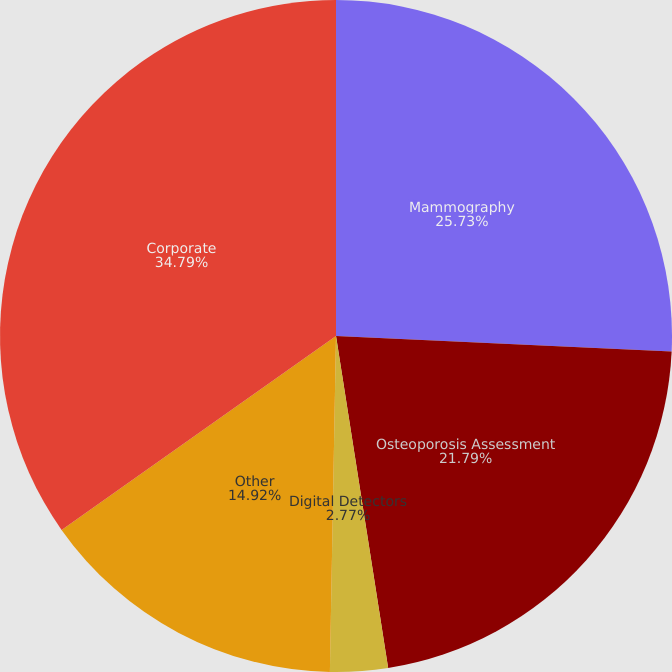<chart> <loc_0><loc_0><loc_500><loc_500><pie_chart><fcel>Mammography<fcel>Osteoporosis Assessment<fcel>Digital Detectors<fcel>Other<fcel>Corporate<nl><fcel>25.73%<fcel>21.79%<fcel>2.77%<fcel>14.92%<fcel>34.79%<nl></chart> 